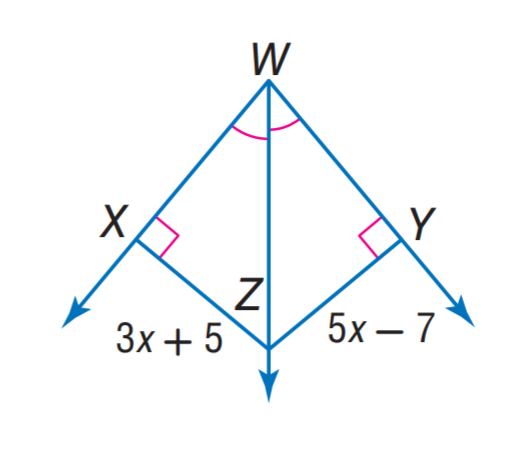Question: Find X Z.
Choices:
A. 5
B. 15
C. 23
D. 35
Answer with the letter. Answer: C 